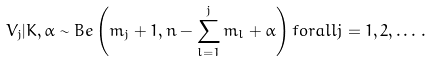<formula> <loc_0><loc_0><loc_500><loc_500>V _ { j } | K , \alpha \sim { B e } \left ( m _ { j } + 1 , n - \sum _ { l = 1 } ^ { j } m _ { l } + \alpha \right ) f o r a l l j = 1 , 2 , \dots \, .</formula> 